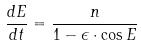Convert formula to latex. <formula><loc_0><loc_0><loc_500><loc_500>\frac { d E } { d t } = \frac { n } { 1 - \epsilon \cdot \cos E }</formula> 